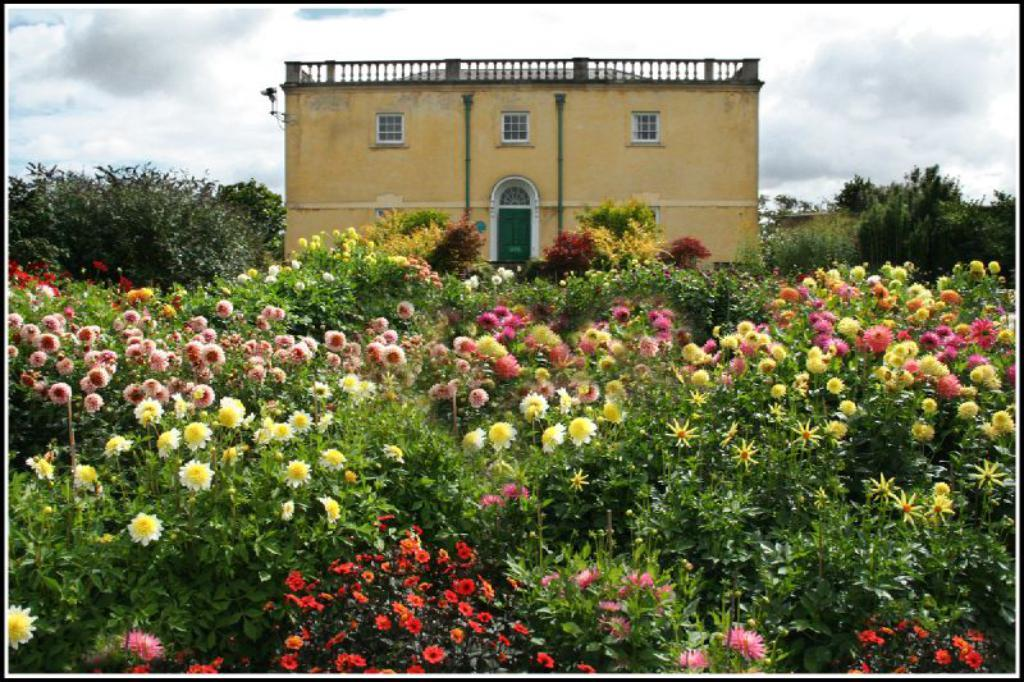What type of plants can be seen in the image? There are beautiful flower plants in the image. Where are the flower plants located in the image? The flower plants are on both the front and back sides of the image. What other structure is present in the image? There is a house in the image. What is the color of the house? The house is in yellow color. What type of apparel is the porter wearing while carrying the basket in the image? There is no porter or basket present in the image; it features flower plants and a yellow house. 